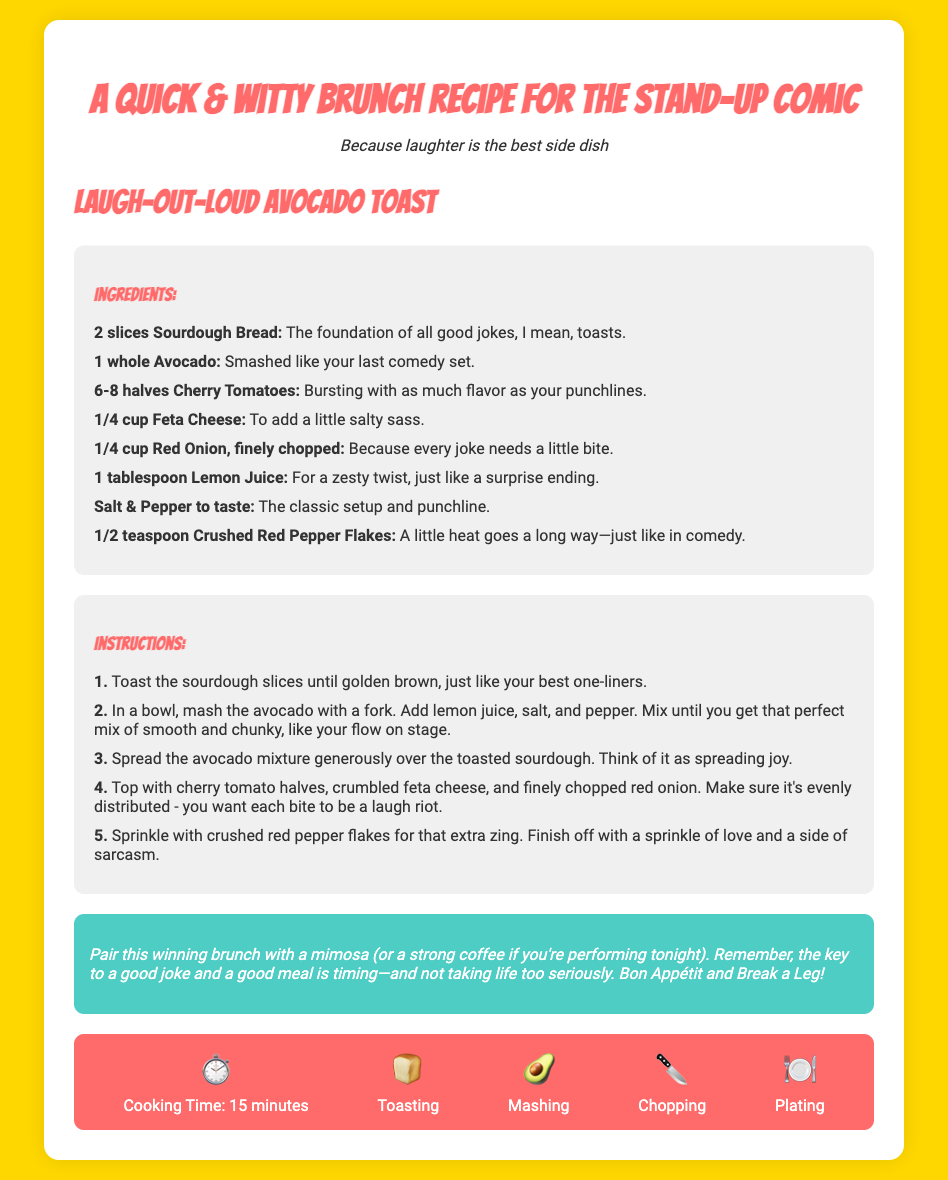What is the title of the recipe? The title can be found at the top of the document, stating the name of the dish.
Answer: A Quick & Witty Brunch Recipe for the Stand-Up Comic How many slices of sourdough bread are needed? The recipe specifies the quantity of each ingredient.
Answer: 2 slices What is the cooking time for the recipe? The cooking time is presented in the infographic section.
Answer: 15 minutes What gives the dish a zesty twist? The ingredient that adds this flavor is mentioned in the ingredients section.
Answer: Lemon Juice What ingredient is described as "smashed like your last comedy set"? This description refers to a specific ingredient in the recipe.
Answer: Avocado How should the avocado mixture be spread on the toast? The instructions provide guidance on how to apply the mix.
Answer: Generously What type of cheese is used in the recipe? The type of cheese can be found in the ingredients list.
Answer: Feta Cheese What should be added for extra zing? This refers to a specific ingredient highlighted in the instructions.
Answer: Crushed Red Pepper Flakes What is the final note's advice about enjoying the meal? This advice summarizes the key takeaway in the final note section.
Answer: Timing—and not taking life too seriously 